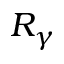<formula> <loc_0><loc_0><loc_500><loc_500>R _ { \gamma }</formula> 